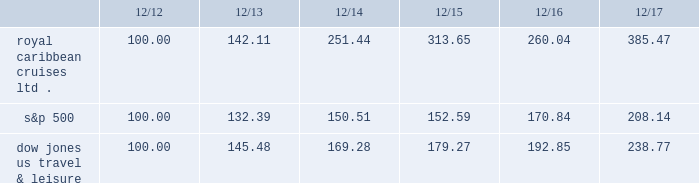Performance graph the following graph compares the total return , assuming reinvestment of dividends , on an investment in the company , based on performance of the company's common stock , with the total return of the standard & poor's 500 composite stock index and the dow jones united states travel and leisure index for a five year period by measuring the changes in common stock prices from december 31 , 2012 to december 31 , 2017. .
The stock performance graph assumes for comparison that the value of the company's common stock and of each index was $ 100 on december 31 , 2012 and that all dividends were reinvested .
Past performance is not necessarily an indicator of future results. .
What was the percentage change in the performance of the company's common stock for royal caribbean cruises ltd from 2013 to 2014? 
Computations: (251.44 - 142.11)
Answer: 109.33. 